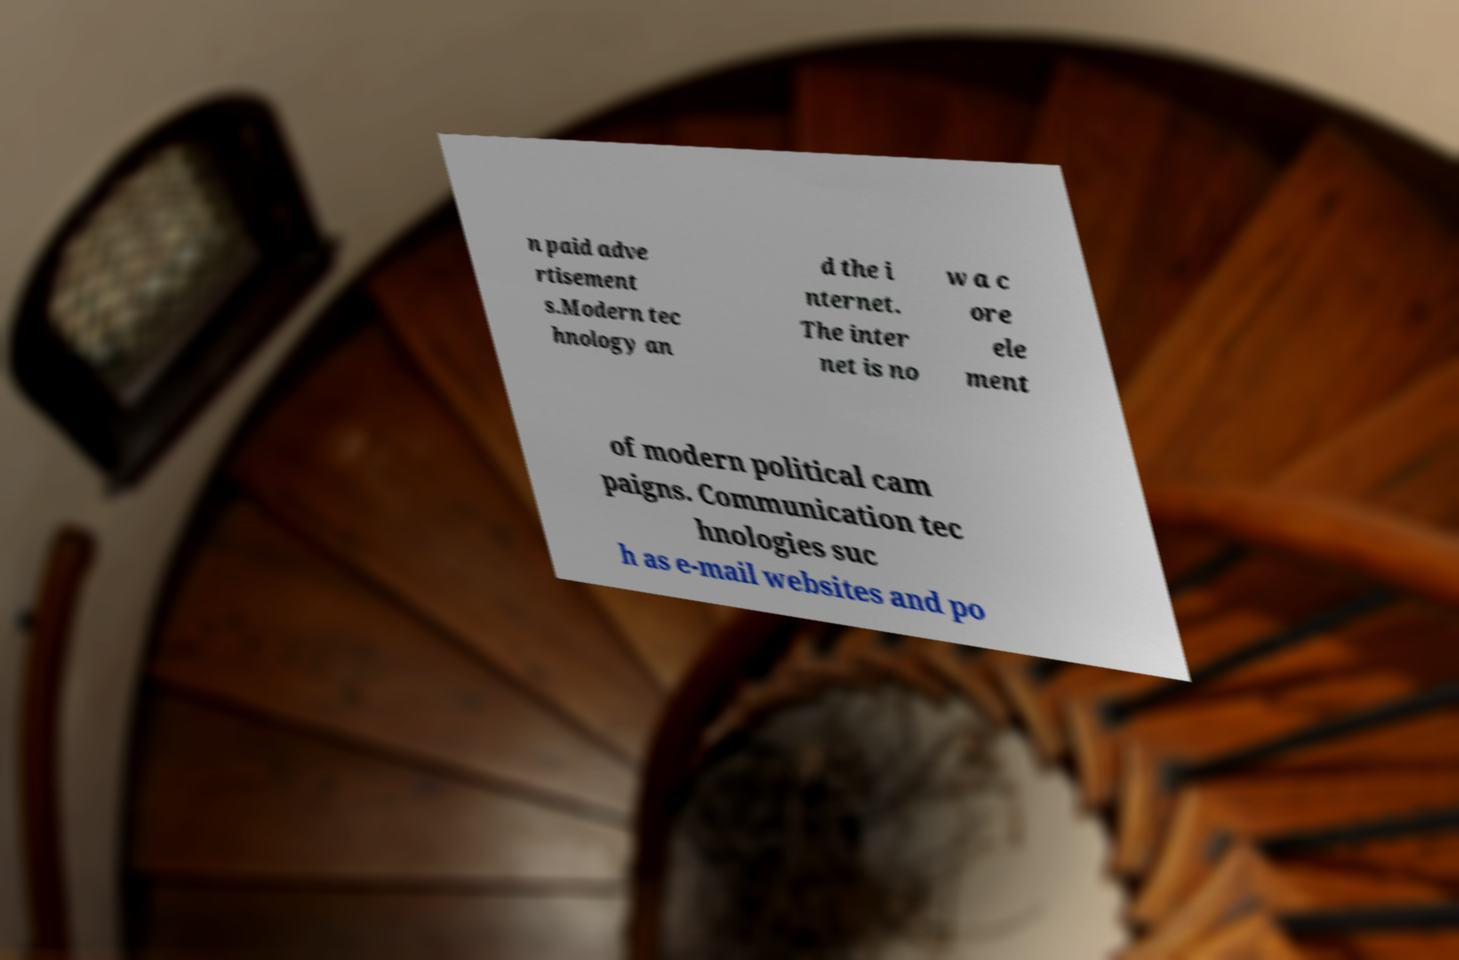For documentation purposes, I need the text within this image transcribed. Could you provide that? n paid adve rtisement s.Modern tec hnology an d the i nternet. The inter net is no w a c ore ele ment of modern political cam paigns. Communication tec hnologies suc h as e-mail websites and po 